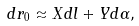Convert formula to latex. <formula><loc_0><loc_0><loc_500><loc_500>d r _ { 0 } \approx X d l + Y d \alpha ,</formula> 